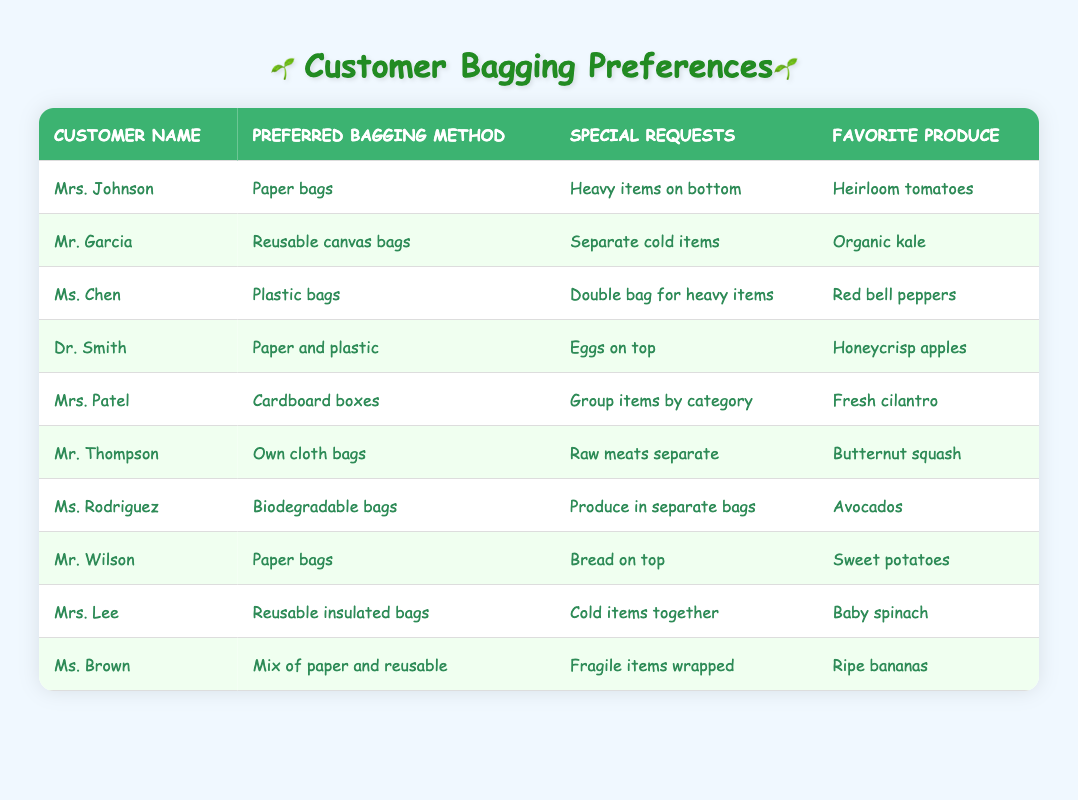What is Mrs. Johnson's favorite produce? In the table, I need to look at the row corresponding to Mrs. Johnson. In that row, the entry under "Favorite Produce" shows "Heirloom tomatoes."
Answer: Heirloom tomatoes Which customer prefers reusable canvas bags? By scanning the "Preferred Bagging Method" column, I find Mr. Garcia listed as preferring reusable canvas bags.
Answer: Mr. Garcia Are there any customers who requested to keep raw meats separate? Focusing on the "Special Requests" column, I find Mr. Thompson who has a request for "Raw meats separate." This indicates that he is one of the customers with this preference.
Answer: Yes What is the total number of customers who prefer paper bags? Looking at the "Preferred Bagging Method" column, I see two entries: Mrs. Johnson and Mr. Wilson. Therefore, I count these two customers for the total.
Answer: 2 Which bagging method is preferred by the most customers, and how many customers prefer it? I assess the "Preferred Bagging Method" column and tally up the occurrences: Paper bags (2), Reusable canvas bags (1), Plastic bags (1), Paper and plastic (1), Cardboard boxes (1), Own cloth bags (1), Biodegradable bags (1), Reusable insulated bags (1), Mix of paper and reusable (1). The method that appears most frequently is paper bags, which has 2 customers.
Answer: Paper bags, 2 What special request does Ms. Brown have? By checking Ms. Brown's row, I look at the "Special Requests" column, which states "Fragile items wrapped." This tells me her specific request during bagging.
Answer: Fragile items wrapped How many customers mentioned they liked avocados? In the "Favorite Produce" column, only one entry shows that Ms. Rodriguez favorites avocados. So, I find just one customer with this preference.
Answer: 1 Is it true that all customers prefer a type of bag made of plastic? I check the "Preferred Bagging Method" column for all entries to see who preferred plastic. Only Ms. Chen prefers plastic bags and others do not, so it’s not true that all customers prefer a plastic type.
Answer: No What do Dr. Smith and Mrs. Lee have in common regarding their bagging preferences? I compare their rows and see that both Dr. Smith and Mrs. Lee have included "Paper" in their bagging methods (Dr. Smith prefers paper and plastic, while Mrs. Lee uses insulated reusable bags). However, further parsing reveals their methods differ; they are not the same.
Answer: Different bagging preferences 